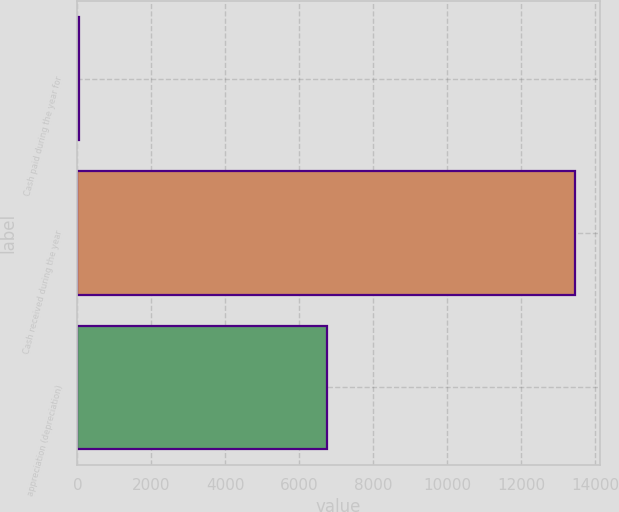Convert chart. <chart><loc_0><loc_0><loc_500><loc_500><bar_chart><fcel>Cash paid during the year for<fcel>Cash received during the year<fcel>appreciation (depreciation)<nl><fcel>41<fcel>13441.6<fcel>6741.3<nl></chart> 